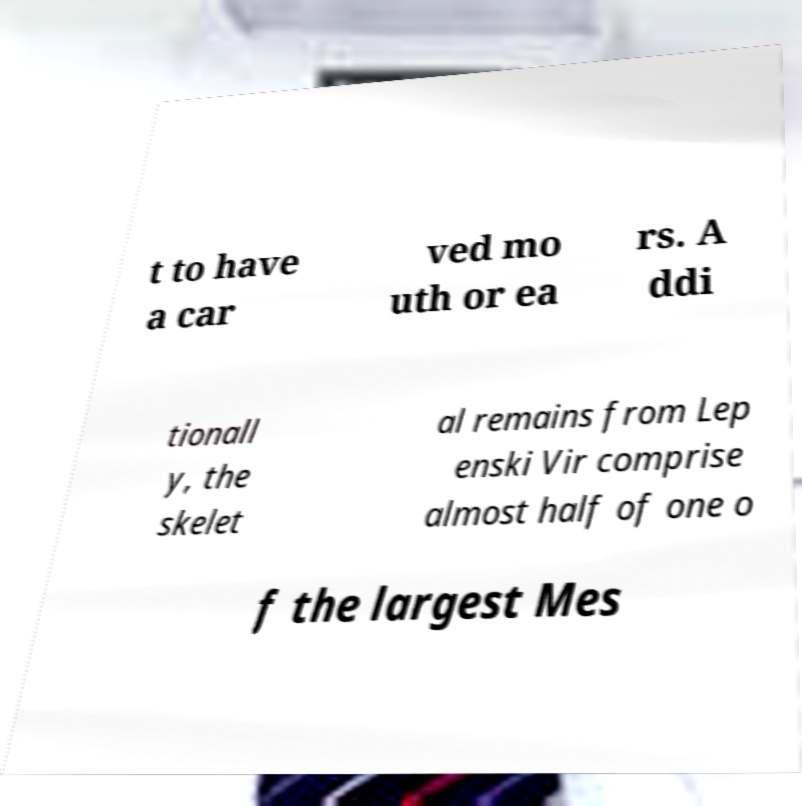There's text embedded in this image that I need extracted. Can you transcribe it verbatim? t to have a car ved mo uth or ea rs. A ddi tionall y, the skelet al remains from Lep enski Vir comprise almost half of one o f the largest Mes 